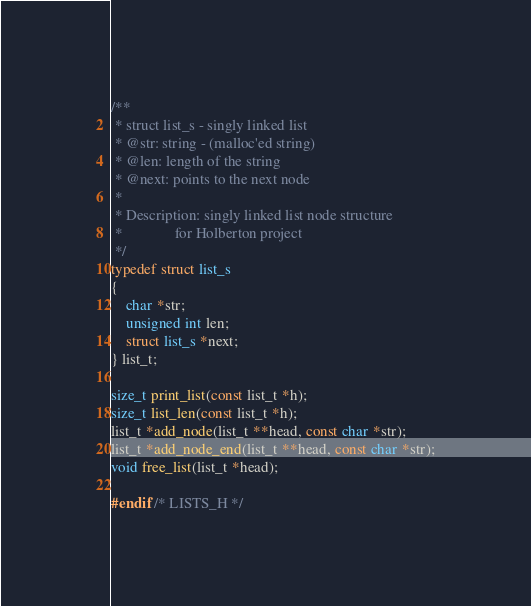<code> <loc_0><loc_0><loc_500><loc_500><_C_>
/**
 * struct list_s - singly linked list
 * @str: string - (malloc'ed string)
 * @len: length of the string
 * @next: points to the next node
 *
 * Description: singly linked list node structure
 *              for Holberton project
 */
typedef struct list_s
{
	char *str;
	unsigned int len;
	struct list_s *next;
} list_t;

size_t print_list(const list_t *h);
size_t list_len(const list_t *h);
list_t *add_node(list_t **head, const char *str);
list_t *add_node_end(list_t **head, const char *str);
void free_list(list_t *head);

#endif /* LISTS_H */
</code> 